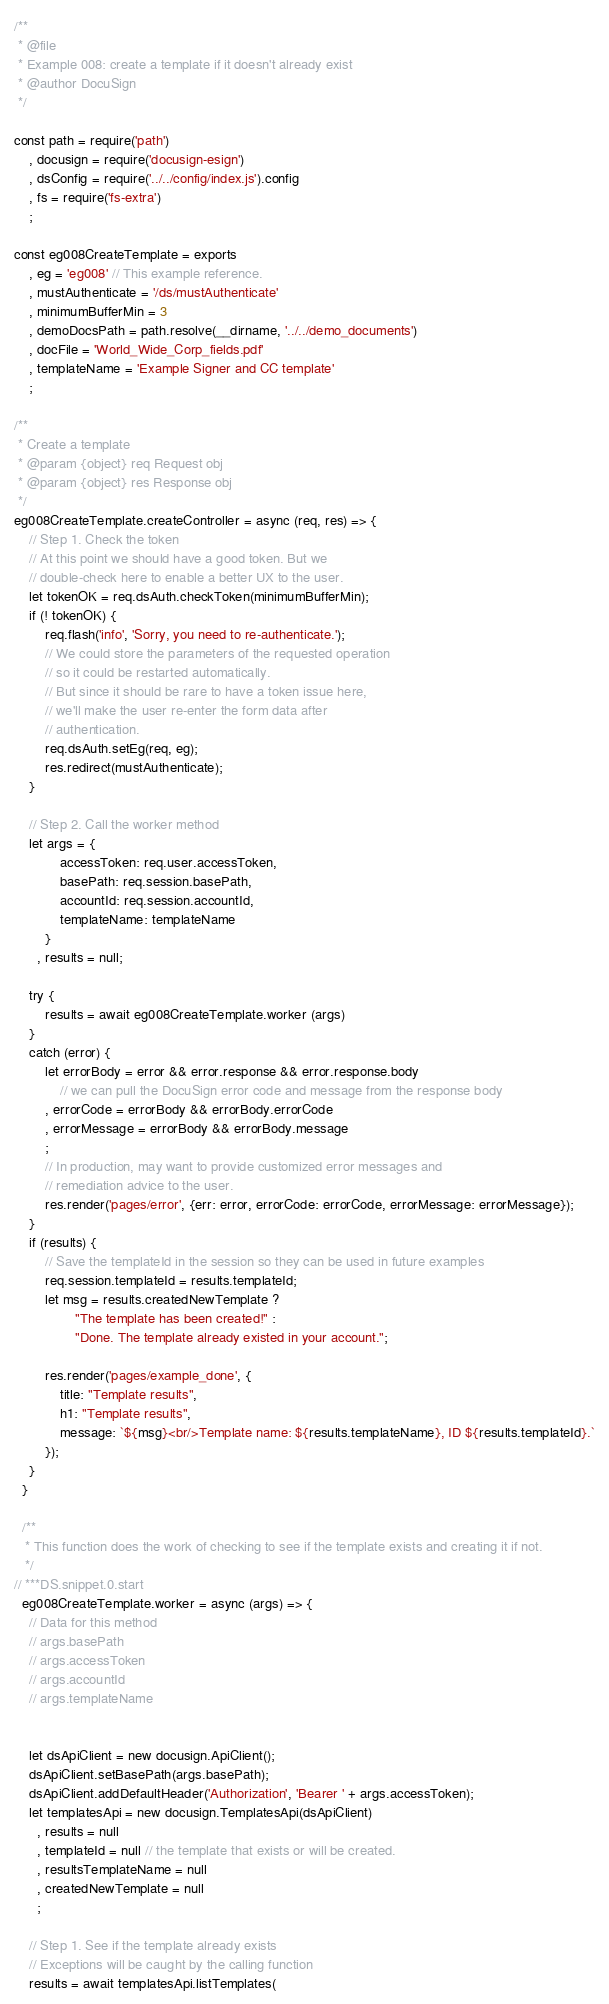<code> <loc_0><loc_0><loc_500><loc_500><_JavaScript_>/**
 * @file
 * Example 008: create a template if it doesn't already exist
 * @author DocuSign
 */

const path = require('path')
    , docusign = require('docusign-esign')
    , dsConfig = require('../../config/index.js').config
    , fs = require('fs-extra')
    ;

const eg008CreateTemplate = exports
    , eg = 'eg008' // This example reference.
    , mustAuthenticate = '/ds/mustAuthenticate'
    , minimumBufferMin = 3
    , demoDocsPath = path.resolve(__dirname, '../../demo_documents')
    , docFile = 'World_Wide_Corp_fields.pdf'
    , templateName = 'Example Signer and CC template'
    ;

/**
 * Create a template
 * @param {object} req Request obj
 * @param {object} res Response obj
 */
eg008CreateTemplate.createController = async (req, res) => {
    // Step 1. Check the token
    // At this point we should have a good token. But we
    // double-check here to enable a better UX to the user.
    let tokenOK = req.dsAuth.checkToken(minimumBufferMin);
    if (! tokenOK) {
        req.flash('info', 'Sorry, you need to re-authenticate.');
        // We could store the parameters of the requested operation
        // so it could be restarted automatically.
        // But since it should be rare to have a token issue here,
        // we'll make the user re-enter the form data after
        // authentication.
        req.dsAuth.setEg(req, eg);
        res.redirect(mustAuthenticate);
    }

    // Step 2. Call the worker method
    let args = {
            accessToken: req.user.accessToken,
            basePath: req.session.basePath,
            accountId: req.session.accountId,
            templateName: templateName
        }
      , results = null;

    try {
        results = await eg008CreateTemplate.worker (args)
    }
    catch (error) {
        let errorBody = error && error.response && error.response.body
            // we can pull the DocuSign error code and message from the response body
        , errorCode = errorBody && errorBody.errorCode
        , errorMessage = errorBody && errorBody.message
        ;
        // In production, may want to provide customized error messages and
        // remediation advice to the user.
        res.render('pages/error', {err: error, errorCode: errorCode, errorMessage: errorMessage});
    }
    if (results) {
        // Save the templateId in the session so they can be used in future examples
        req.session.templateId = results.templateId;
        let msg = results.createdNewTemplate ?
                "The template has been created!" :
                "Done. The template already existed in your account.";

        res.render('pages/example_done', {
            title: "Template results",
            h1: "Template results",
            message: `${msg}<br/>Template name: ${results.templateName}, ID ${results.templateId}.`
        });
    }
  }

  /**
   * This function does the work of checking to see if the template exists and creating it if not.
   */
// ***DS.snippet.0.start
  eg008CreateTemplate.worker = async (args) => {
    // Data for this method
    // args.basePath
    // args.accessToken
    // args.accountId
    // args.templateName


    let dsApiClient = new docusign.ApiClient();
    dsApiClient.setBasePath(args.basePath);
    dsApiClient.addDefaultHeader('Authorization', 'Bearer ' + args.accessToken);
    let templatesApi = new docusign.TemplatesApi(dsApiClient)
      , results = null
      , templateId = null // the template that exists or will be created.
      , resultsTemplateName = null
      , createdNewTemplate = null
      ;

    // Step 1. See if the template already exists
    // Exceptions will be caught by the calling function
    results = await templatesApi.listTemplates(</code> 